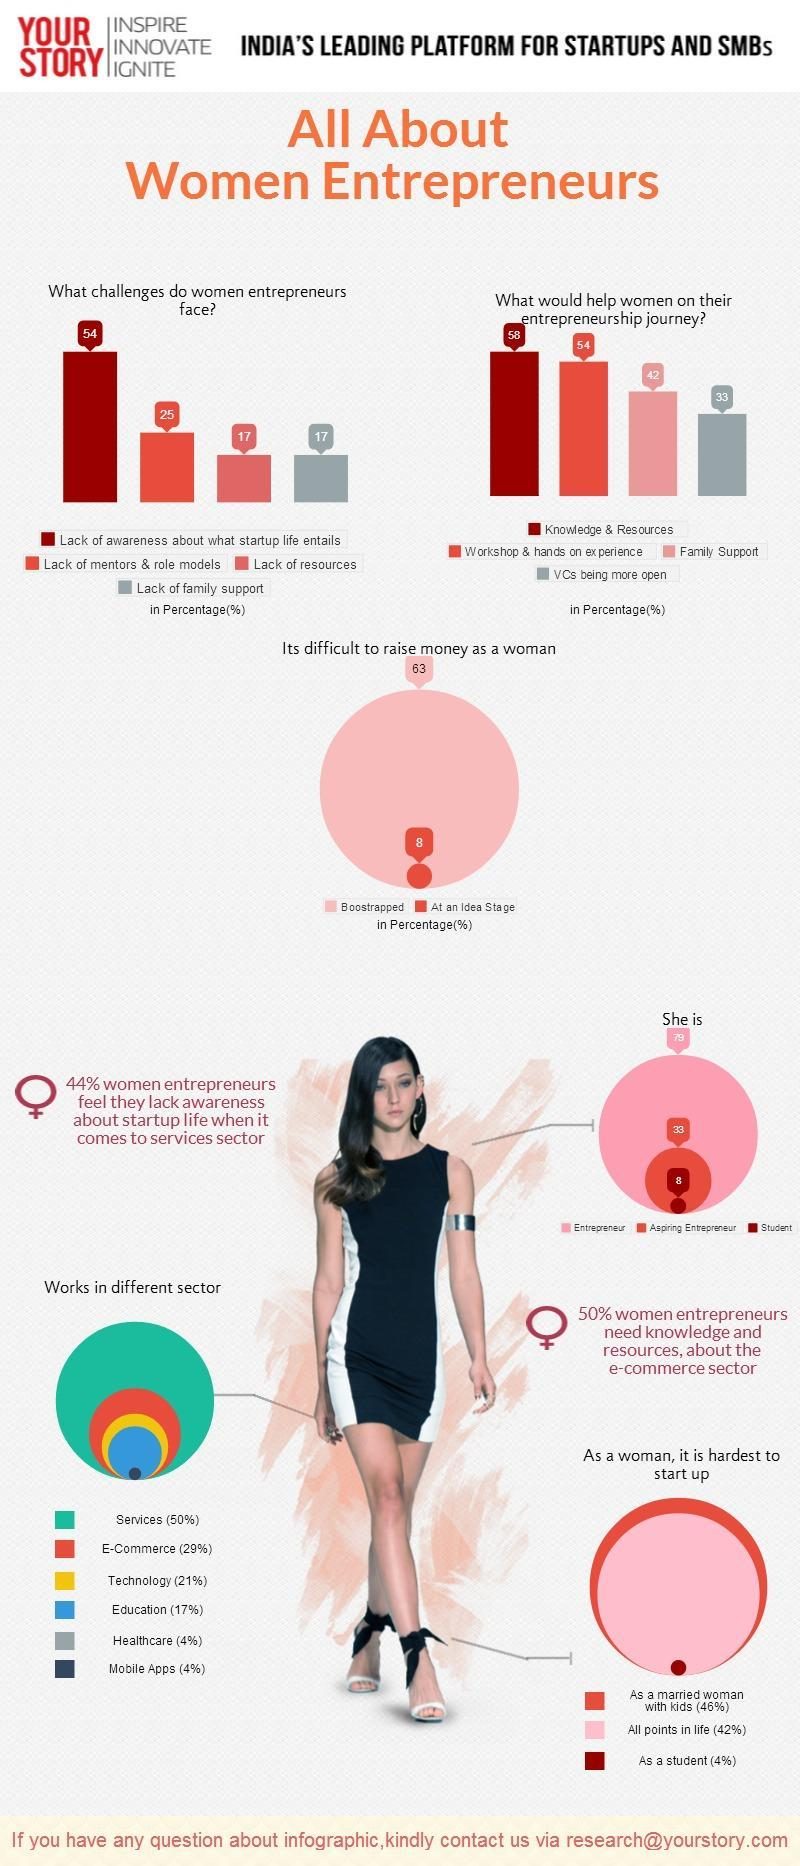What percentage of the Indian women are Students?
Answer the question with a short phrase. 8 How many women entrepreneurs have issues with less no of resources? 17 What is the third factor that helps women entrepreneurs to gain success? Family Support What percentage of Indian women are Entrepreneurs? 79 What is the color code given to the Education sector- red, green, blue, yellow? blue In which sector second largest no of women are working? E-commerce What is the second-largest difficulty faced by women entrepreneurs? Lack of Mentors & role models What percentage of women in India want to become entrepreneurs? 33 Women belonging to which category face the most difficulty in a start-up business? As a married women with kids What is the color code given to the Technology sector- red, green, yellow, blue? yellow 